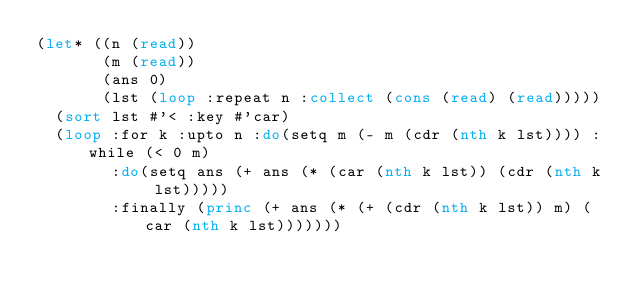<code> <loc_0><loc_0><loc_500><loc_500><_Lisp_>(let* ((n (read))
       (m (read))
       (ans 0)
       (lst (loop :repeat n :collect (cons (read) (read)))))
  (sort lst #'< :key #'car)
  (loop :for k :upto n :do(setq m (- m (cdr (nth k lst)))) :while (< 0 m)
        :do(setq ans (+ ans (* (car (nth k lst)) (cdr (nth k lst)))))
        :finally (princ (+ ans (* (+ (cdr (nth k lst)) m) (car (nth k lst)))))))</code> 